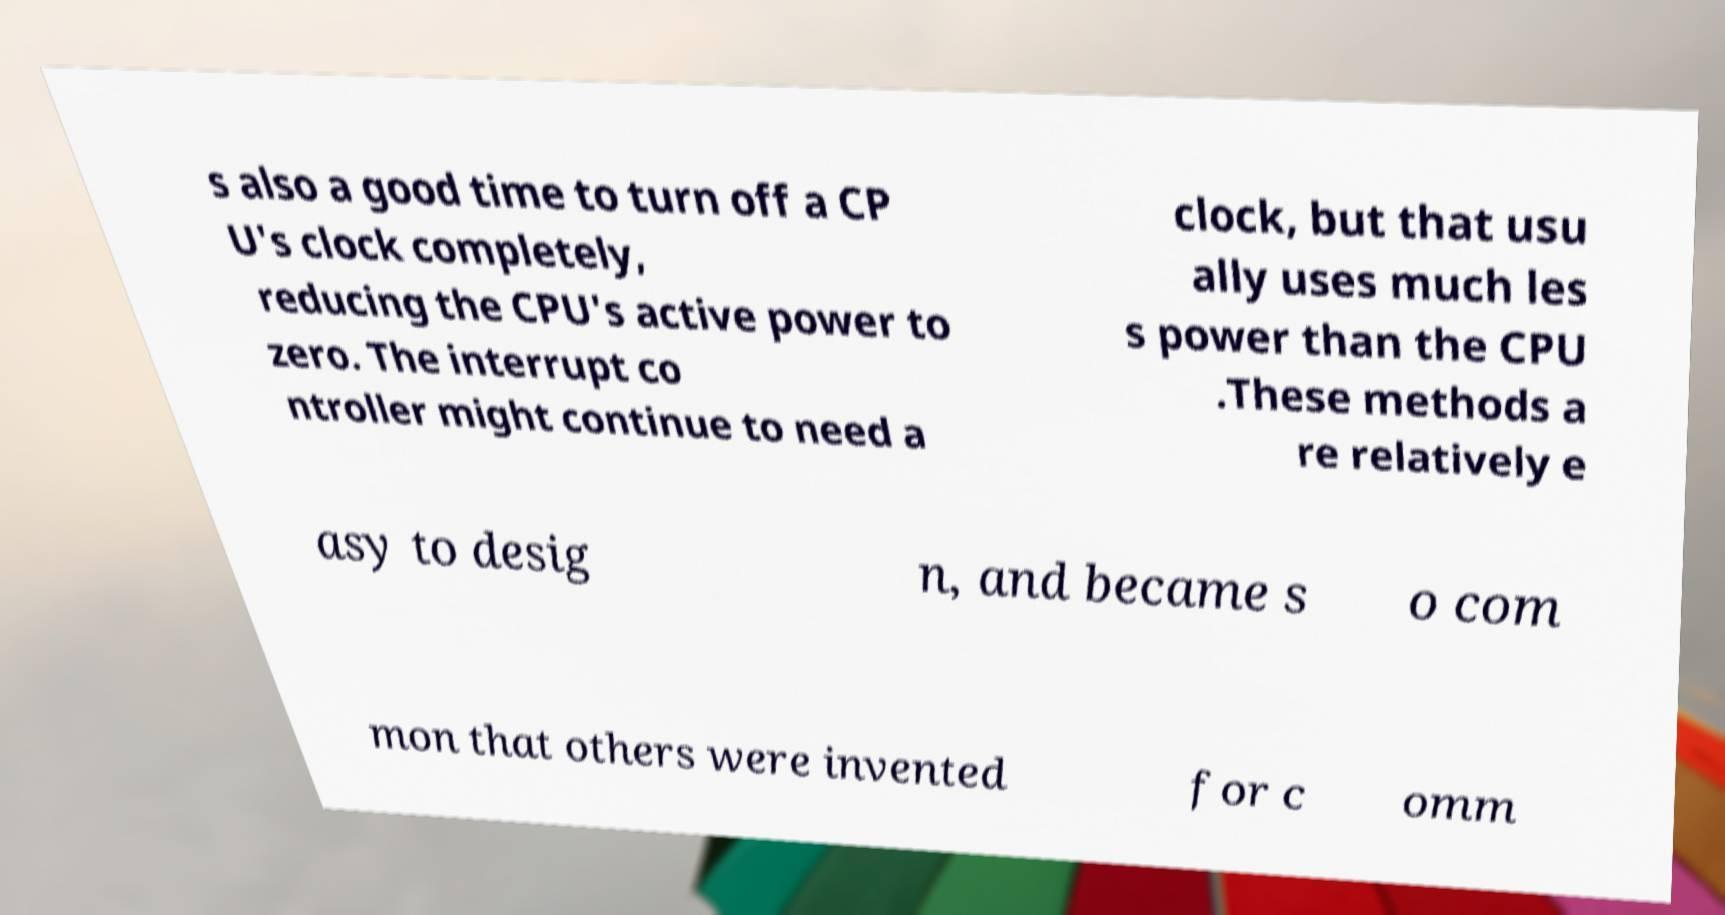Could you extract and type out the text from this image? s also a good time to turn off a CP U's clock completely, reducing the CPU's active power to zero. The interrupt co ntroller might continue to need a clock, but that usu ally uses much les s power than the CPU .These methods a re relatively e asy to desig n, and became s o com mon that others were invented for c omm 